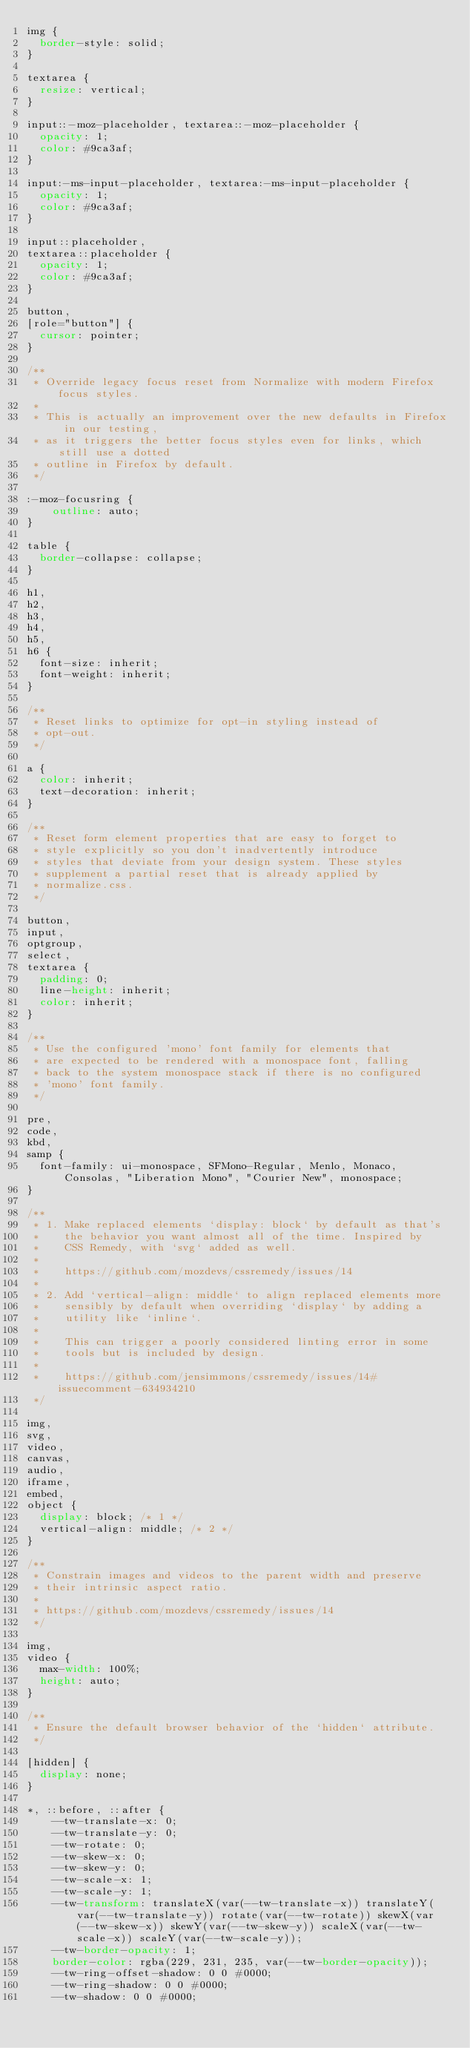<code> <loc_0><loc_0><loc_500><loc_500><_CSS_>img {
  border-style: solid;
}

textarea {
  resize: vertical;
}

input::-moz-placeholder, textarea::-moz-placeholder {
  opacity: 1;
  color: #9ca3af;
}

input:-ms-input-placeholder, textarea:-ms-input-placeholder {
  opacity: 1;
  color: #9ca3af;
}

input::placeholder,
textarea::placeholder {
  opacity: 1;
  color: #9ca3af;
}

button,
[role="button"] {
  cursor: pointer;
}

/**
 * Override legacy focus reset from Normalize with modern Firefox focus styles.
 *
 * This is actually an improvement over the new defaults in Firefox in our testing,
 * as it triggers the better focus styles even for links, which still use a dotted
 * outline in Firefox by default.
 */
 
:-moz-focusring {
	outline: auto;
}

table {
  border-collapse: collapse;
}

h1,
h2,
h3,
h4,
h5,
h6 {
  font-size: inherit;
  font-weight: inherit;
}

/**
 * Reset links to optimize for opt-in styling instead of
 * opt-out.
 */

a {
  color: inherit;
  text-decoration: inherit;
}

/**
 * Reset form element properties that are easy to forget to
 * style explicitly so you don't inadvertently introduce
 * styles that deviate from your design system. These styles
 * supplement a partial reset that is already applied by
 * normalize.css.
 */

button,
input,
optgroup,
select,
textarea {
  padding: 0;
  line-height: inherit;
  color: inherit;
}

/**
 * Use the configured 'mono' font family for elements that
 * are expected to be rendered with a monospace font, falling
 * back to the system monospace stack if there is no configured
 * 'mono' font family.
 */

pre,
code,
kbd,
samp {
  font-family: ui-monospace, SFMono-Regular, Menlo, Monaco, Consolas, "Liberation Mono", "Courier New", monospace;
}

/**
 * 1. Make replaced elements `display: block` by default as that's
 *    the behavior you want almost all of the time. Inspired by
 *    CSS Remedy, with `svg` added as well.
 *
 *    https://github.com/mozdevs/cssremedy/issues/14
 * 
 * 2. Add `vertical-align: middle` to align replaced elements more
 *    sensibly by default when overriding `display` by adding a
 *    utility like `inline`.
 *
 *    This can trigger a poorly considered linting error in some
 *    tools but is included by design.
 * 
 *    https://github.com/jensimmons/cssremedy/issues/14#issuecomment-634934210
 */

img,
svg,
video,
canvas,
audio,
iframe,
embed,
object {
  display: block; /* 1 */
  vertical-align: middle; /* 2 */
}

/**
 * Constrain images and videos to the parent width and preserve
 * their intrinsic aspect ratio.
 *
 * https://github.com/mozdevs/cssremedy/issues/14
 */

img,
video {
  max-width: 100%;
  height: auto;
}

/**
 * Ensure the default browser behavior of the `hidden` attribute.
 */

[hidden] {
  display: none;
}

*, ::before, ::after {
	--tw-translate-x: 0;
	--tw-translate-y: 0;
	--tw-rotate: 0;
	--tw-skew-x: 0;
	--tw-skew-y: 0;
	--tw-scale-x: 1;
	--tw-scale-y: 1;
	--tw-transform: translateX(var(--tw-translate-x)) translateY(var(--tw-translate-y)) rotate(var(--tw-rotate)) skewX(var(--tw-skew-x)) skewY(var(--tw-skew-y)) scaleX(var(--tw-scale-x)) scaleY(var(--tw-scale-y));
	--tw-border-opacity: 1;
	border-color: rgba(229, 231, 235, var(--tw-border-opacity));
	--tw-ring-offset-shadow: 0 0 #0000;
	--tw-ring-shadow: 0 0 #0000;
	--tw-shadow: 0 0 #0000;</code> 